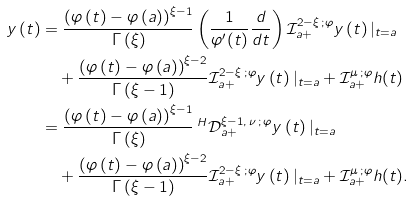<formula> <loc_0><loc_0><loc_500><loc_500>y \left ( t \right ) & = \frac { \left ( \varphi \left ( t \right ) - \varphi \left ( a \right ) \right ) ^ { \xi - 1 } } { \Gamma \left ( \xi \right ) } \left ( \frac { 1 } { \varphi ^ { \prime } ( t ) } \frac { d } { d t } \right ) \mathcal { I } _ { a + } ^ { 2 - \xi \, ; \varphi } y \left ( t \right ) | _ { t = a } \\ & \quad + \frac { \left ( \varphi \left ( t \right ) - \varphi \left ( a \right ) \right ) ^ { \xi - 2 } } { \Gamma \left ( \xi - 1 \right ) } \mathcal { I } _ { a + } ^ { 2 - \xi \, ; \varphi } y \left ( t \right ) | _ { t = a } + \mathcal { I } _ { a + } ^ { \mu \, ; \varphi } h ( t ) \\ & = \frac { \left ( \varphi \left ( t \right ) - \varphi \left ( a \right ) \right ) ^ { \xi - 1 } } { \Gamma \left ( \xi \right ) } \, ^ { H } \mathcal { D } ^ { \xi - 1 , \, \nu \, ; \, \varphi } _ { a + } y \left ( t \right ) | _ { t = a } \\ & \quad + \frac { \left ( \varphi \left ( t \right ) - \varphi \left ( a \right ) \right ) ^ { \xi - 2 } } { \Gamma \left ( \xi - 1 \right ) } \mathcal { I } _ { a + } ^ { 2 - \xi \, ; \varphi } y \left ( t \right ) | _ { t = a } + \mathcal { I } _ { a + } ^ { \mu \, ; \varphi } h ( t ) .</formula> 